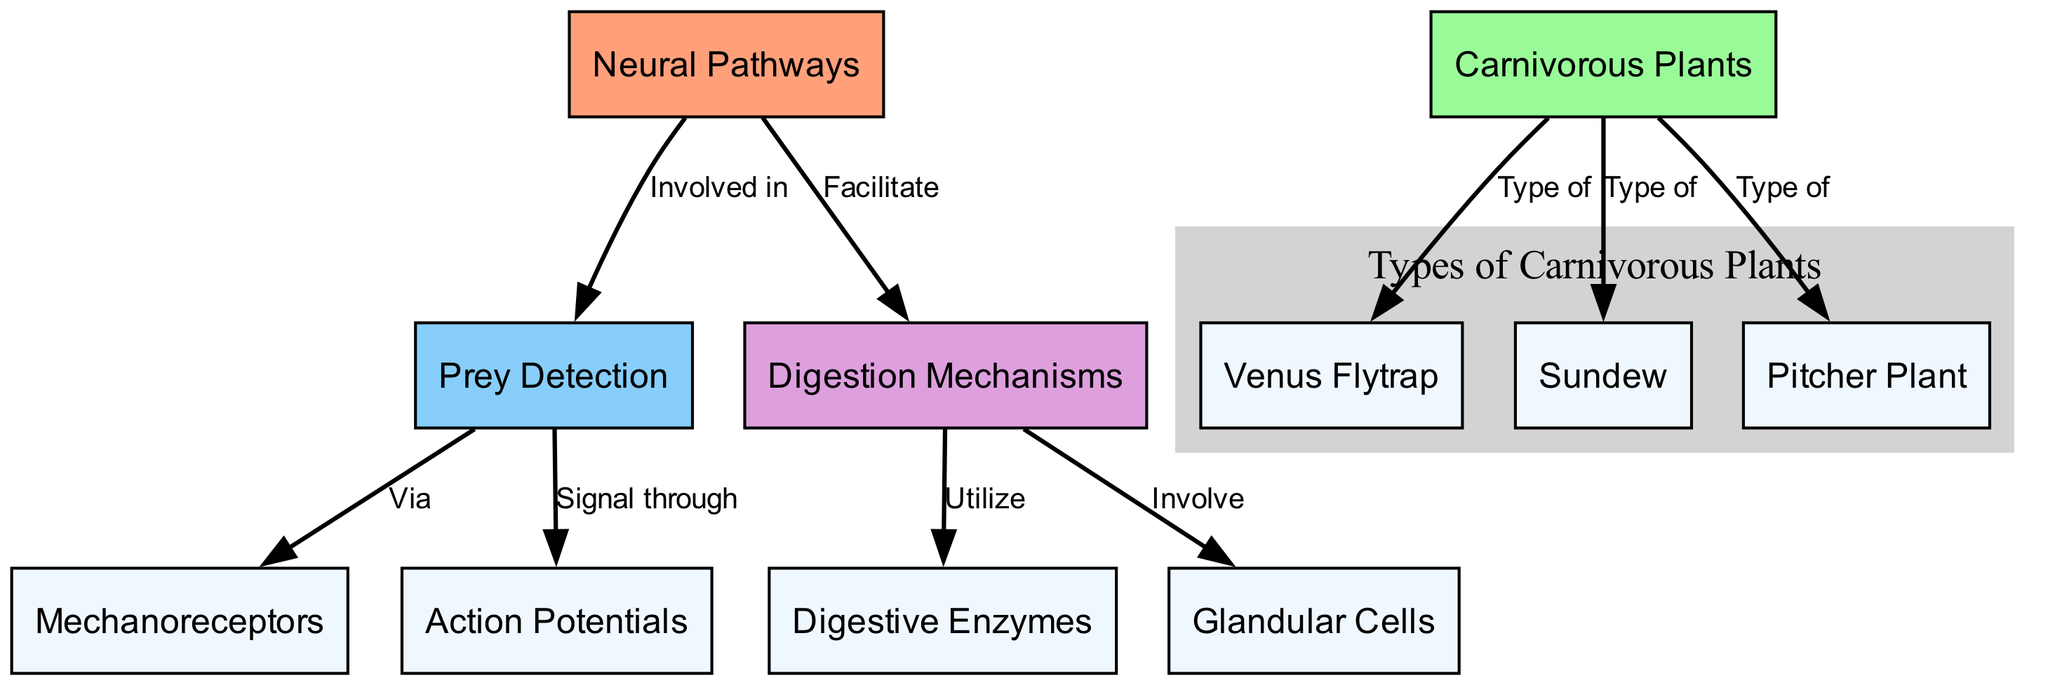What are the three types of carnivorous plants shown in the diagram? The diagram lists three specific types of carnivorous plants: Venus Flytrap, Sundew, and Pitcher Plant. These are distinctly labeled in the types of carnivorous plants section.
Answer: Venus Flytrap, Sundew, Pitcher Plant How many nodes are present in the diagram? To find the total number of nodes, we count each unique entry listed. There are 11 nodes in total as defined at the beginning of the diagram.
Answer: 11 What mechanism do carnivorous plants use for prey detection? The diagram indicates that prey detection is achieved via mechanoreceptors, which are a specific type of sensor that reacts to physical stimuli.
Answer: Mechanoreceptors What do digestion mechanisms utilize? According to the diagram, digestion mechanisms utilize digestive enzymes to break down prey after it has been captured. This is indicated in the relating edge leading to digestive enzymes.
Answer: Digestive Enzymes Which node is involved in both prey detection and digestion mechanisms? The neural pathways node links to both prey detection and digestion mechanisms, indicating its crucial role in these functions within carnivorous plants.
Answer: Neural Pathways What signals are involved in prey detection? The two signals involved in prey detection are action potentials and mechanoreceptors, as shown in the diagram, linking them to the prey detection node.
Answer: Action Potentials, Mechanoreceptors How do neural pathways facilitate digestion mechanisms? The diagram illustrates that neural pathways facilitate digestion mechanisms by connecting directly to them, indicating a supportive relationship between the two processes.
Answer: Facilitate Which carnivorous plant uses glandular cells in its digestion process? The digestion mechanisms segment of the diagram shows that glandular cells are involved in the digestion process for carnivorous plants.
Answer: Glandular Cells What is the overall purpose of the neural pathways in carnivorous plants? The neural pathways in carnivorous plants serve the overall purpose of enabling prey detection and facilitating digestion, highlighting a functional role in both capturing and processing prey.
Answer: Enable prey detection and facilitate digestion 